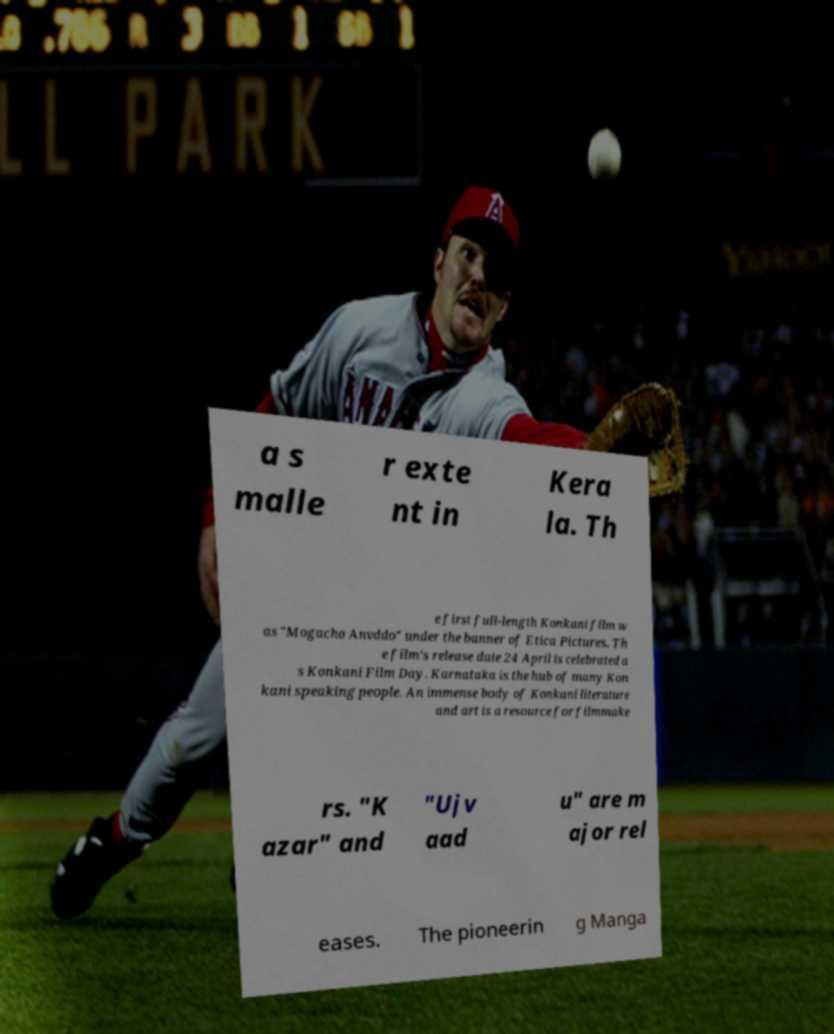Can you accurately transcribe the text from the provided image for me? a s malle r exte nt in Kera la. Th e first full-length Konkani film w as "Mogacho Anvddo" under the banner of Etica Pictures. Th e film's release date 24 April is celebrated a s Konkani Film Day. Karnataka is the hub of many Kon kani speaking people. An immense body of Konkani literature and art is a resource for filmmake rs. "K azar" and "Ujv aad u" are m ajor rel eases. The pioneerin g Manga 